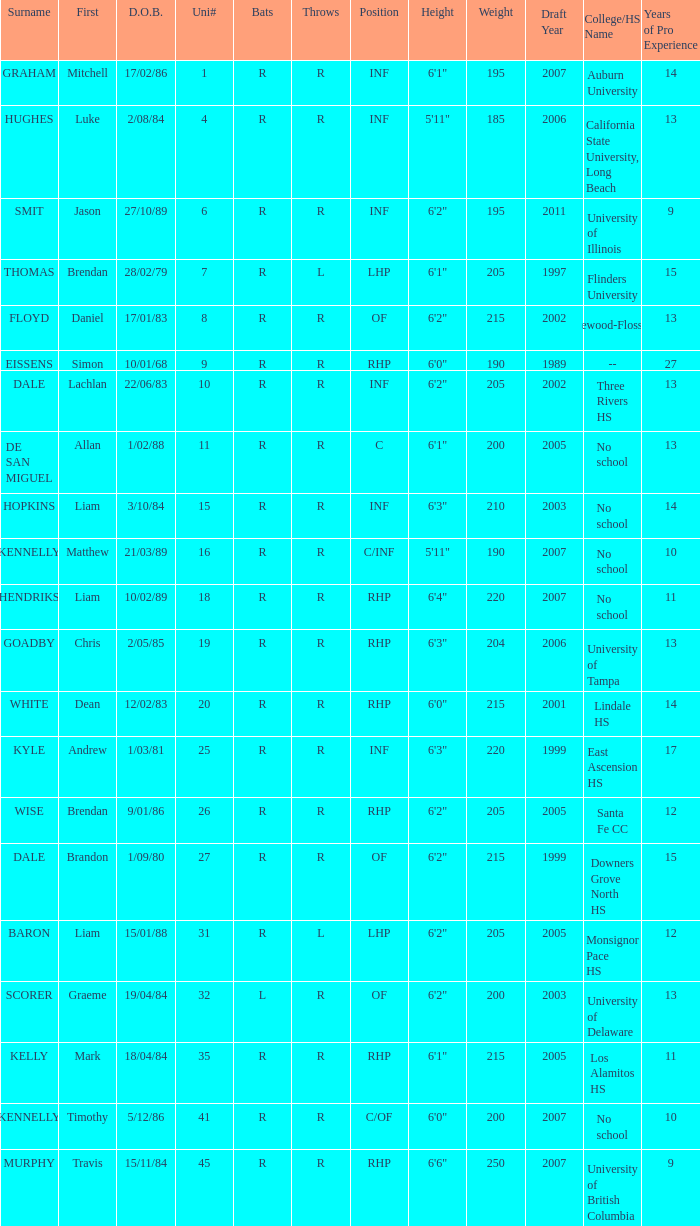Which offensive player has a uni# of 31? R. Help me parse the entirety of this table. {'header': ['Surname', 'First', 'D.O.B.', 'Uni#', 'Bats', 'Throws', 'Position', 'Height', 'Weight', 'Draft Year', 'College/HS Name', 'Years of Pro Experience'], 'rows': [['GRAHAM', 'Mitchell', '17/02/86', '1', 'R', 'R', 'INF', '6\'1"', '195', '2007', 'Auburn University', '14'], ['HUGHES', 'Luke', '2/08/84', '4', 'R', 'R', 'INF', '5\'11"', '185', '2006', 'California State University, Long Beach', '13'], ['SMIT', 'Jason', '27/10/89', '6', 'R', 'R', 'INF', '6\'2"', '195', '2011', 'University of Illinois', '9'], ['THOMAS', 'Brendan', '28/02/79', '7', 'R', 'L', 'LHP', '6\'1"', '205', '1997', 'Flinders University', '15'], ['FLOYD', 'Daniel', '17/01/83', '8', 'R', 'R', 'OF', '6\'2"', '215', '2002', 'Homewood-Flossmoor HS', '13'], ['EISSENS', 'Simon', '10/01/68', '9', 'R', 'R', 'RHP', '6\'0"', '190', '1989', '--', '27'], ['DALE', 'Lachlan', '22/06/83', '10', 'R', 'R', 'INF', '6\'2"', '205', '2002', 'Three Rivers HS', '13'], ['DE SAN MIGUEL', 'Allan', '1/02/88', '11', 'R', 'R', 'C', '6\'1"', '200', '2005', 'No school', '13'], ['HOPKINS', 'Liam', '3/10/84', '15', 'R', 'R', 'INF', '6\'3"', '210', '2003', 'No school', '14'], ['KENNELLY', 'Matthew', '21/03/89', '16', 'R', 'R', 'C/INF', '5\'11"', '190', '2007', 'No school', '10'], ['HENDRIKS', 'Liam', '10/02/89', '18', 'R', 'R', 'RHP', '6\'4"', '220', '2007', 'No school', '11'], ['GOADBY', 'Chris', '2/05/85', '19', 'R', 'R', 'RHP', '6\'3"', '204', '2006', 'University of Tampa', '13'], ['WHITE', 'Dean', '12/02/83', '20', 'R', 'R', 'RHP', '6\'0"', '215', '2001', 'Lindale HS', '14'], ['KYLE', 'Andrew', '1/03/81', '25', 'R', 'R', 'INF', '6\'3"', '220', '1999', 'East Ascension HS', '17'], ['WISE', 'Brendan', '9/01/86', '26', 'R', 'R', 'RHP', '6\'2"', '205', '2005', 'Santa Fe CC', '12'], ['DALE', 'Brandon', '1/09/80', '27', 'R', 'R', 'OF', '6\'2"', '215', '1999', 'Downers Grove North HS', '15'], ['BARON', 'Liam', '15/01/88', '31', 'R', 'L', 'LHP', '6\'2"', '205', '2005', 'Monsignor Pace HS', '12'], ['SCORER', 'Graeme', '19/04/84', '32', 'L', 'R', 'OF', '6\'2"', '200', '2003', 'University of Delaware', '13'], ['KELLY', 'Mark', '18/04/84', '35', 'R', 'R', 'RHP', '6\'1"', '215', '2005', 'Los Alamitos HS', '11'], ['KENNELLY', 'Timothy', '5/12/86', '41', 'R', 'R', 'C/OF', '6\'0"', '200', '2007', 'No school', '10'], ['MURPHY', 'Travis', '15/11/84', '45', 'R', 'R', 'RHP', '6\'6"', '250', '2007', 'University of British Columbia', '9']]} 